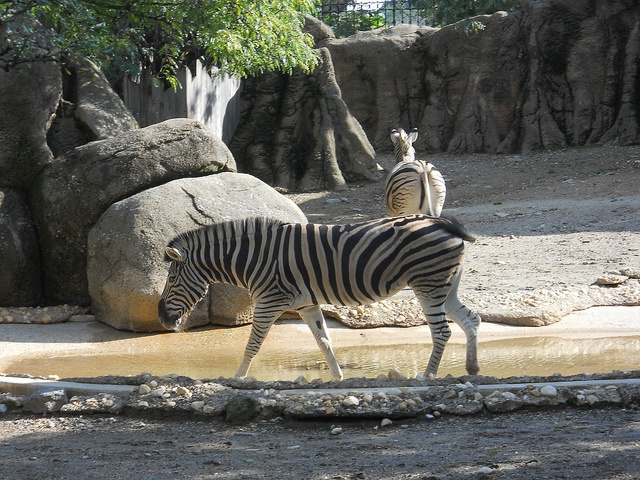Describe the objects in this image and their specific colors. I can see zebra in darkgreen, gray, black, and darkgray tones and zebra in darkgreen, gray, ivory, and darkgray tones in this image. 